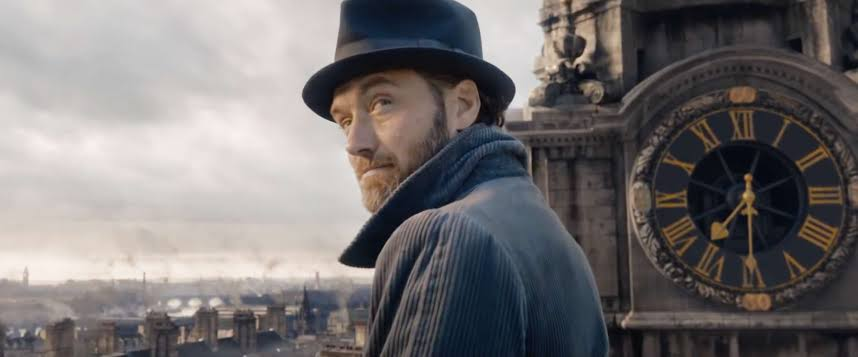What emotion does the man's expression convey? The man's expression conveys a sense of solemnity and introspective thought, hinting at a weighty decision or profound realization that concerns him deeply. 